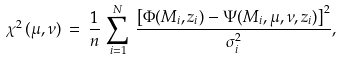<formula> <loc_0><loc_0><loc_500><loc_500>\chi ^ { 2 } \, ( \mu , \nu ) \, = \, \frac { 1 } { n } \, \sum _ { i = 1 } ^ { N } \, \frac { \left [ \Phi ( M _ { i } , z _ { i } ) - \Psi ( M _ { i } , \mu , \nu , z _ { i } ) \right ] ^ { 2 } } { \sigma _ { i } ^ { 2 } } ,</formula> 